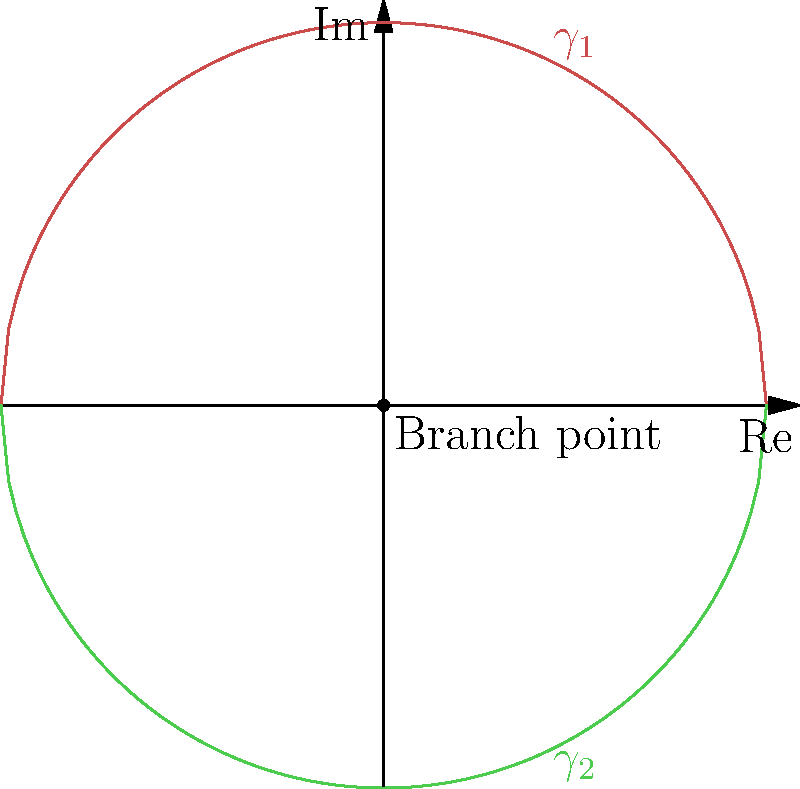Consider the Riemann surface representation of the complex square root function shown above. How many times must a path encircle the branch point at the origin to return to its starting position on the same sheet? How might this property be utilized in modeling multi-valued data structures for secure information encoding? To answer this question, we need to understand the properties of Riemann surfaces and branch points:

1. The complex square root function is multi-valued, meaning it has two possible values for each non-zero complex number.

2. The Riemann surface for this function consists of two sheets ($\gamma_1$ and $\gamma_2$) connected at a branch point (the origin).

3. When following a path around the branch point:
   a. Starting on $\gamma_1$ and making one full rotation takes you to $\gamma_2$.
   b. Another full rotation brings you back to $\gamma_1$.

4. Therefore, it takes two complete rotations around the branch point to return to the starting position on the same sheet.

5. This property can be utilized in modeling multi-valued data structures for secure information encoding:
   a. Data can be mapped onto different sheets of the Riemann surface.
   b. The number of rotations needed to access specific data points can serve as an additional layer of encryption.
   c. The branch point can act as a "key" for decoding the information.
   d. Multiple branch points and more complex Riemann surfaces can create highly intricate encoding schemes.

6. For national security applications:
   a. This approach can help in creating robust encryption methods for sensitive data.
   b. It can also be used to model complex, interconnected data structures that require multiple "levels" of access or interpretation.
Answer: Two rotations; enables multi-level data encryption and complex structural modeling. 